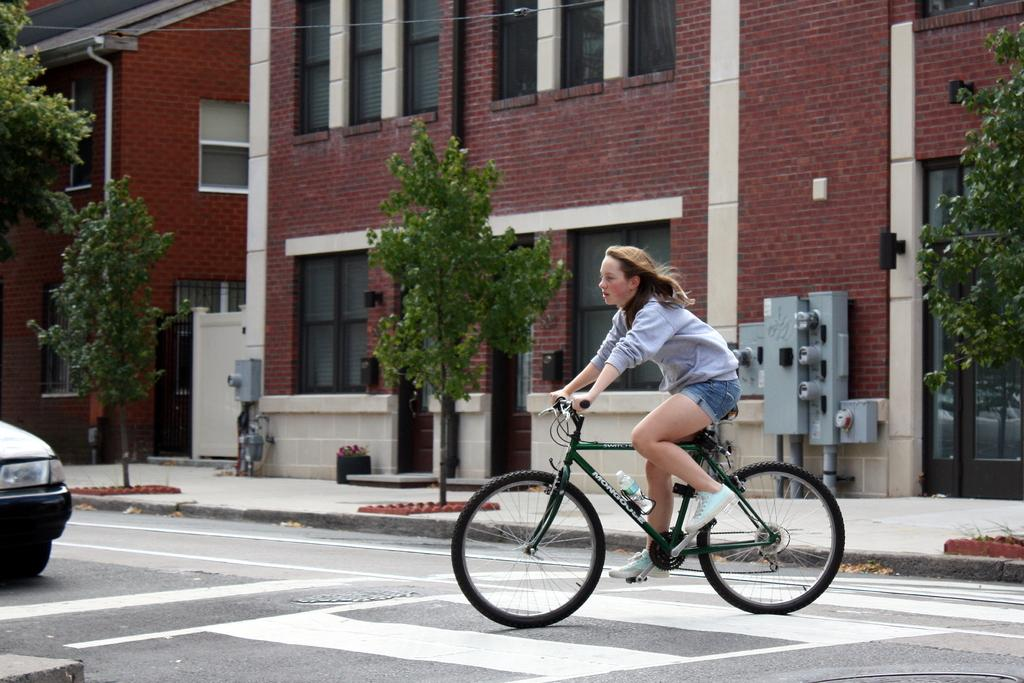Who is the main subject in the image? There is a lady in the image. What is the lady doing in the image? The lady is riding a bicycle. Where is the bicycle located in the image? The bicycle is on a zebra crossing. What else can be seen in the image? There is a vehicle on the left side of the image. What type of relation does the lady have with the vehicle in the image? There is no indication of a relation between the lady and the vehicle in the image. Can you describe how the lady is rubbing the bicycle in the image? The lady is not rubbing the bicycle the bicycle in the image; she is riding it. 